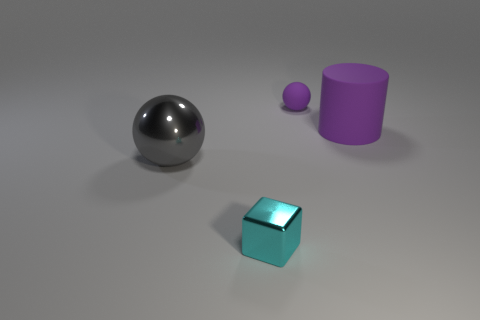Add 4 large brown cylinders. How many objects exist? 8 Subtract all cubes. How many objects are left? 3 Subtract all big green rubber balls. Subtract all small cubes. How many objects are left? 3 Add 4 purple balls. How many purple balls are left? 5 Add 2 big yellow rubber blocks. How many big yellow rubber blocks exist? 2 Subtract 0 brown cylinders. How many objects are left? 4 